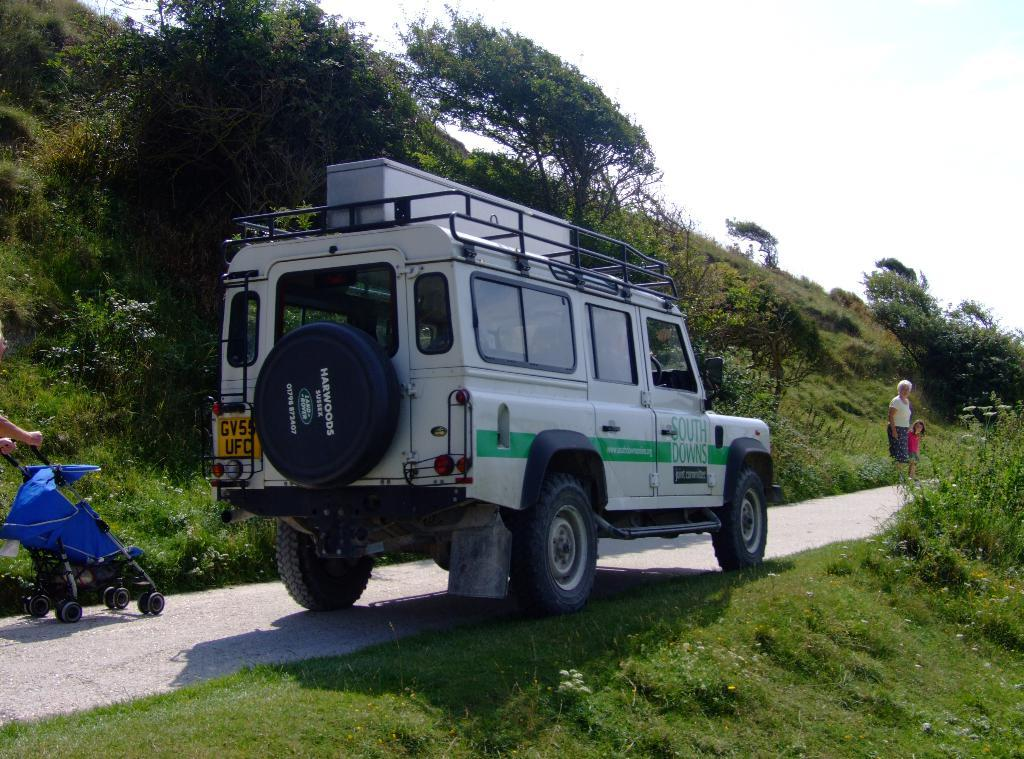What type of vehicle is present in the image? There is a baby trolley and a car in the image. What are the people in the image doing? Two people are walking on the road in the image. What type of surface is visible beside the road? There is grass on the surface beside the road in the image. What type of vegetation can be seen in the image? There are trees in the image. What type of club can be seen in the image? There is no club present in the image. How does the baby trolley provide comfort to the baby? The image does not show the baby trolley providing comfort to the baby, as it only depicts the trolley itself. 